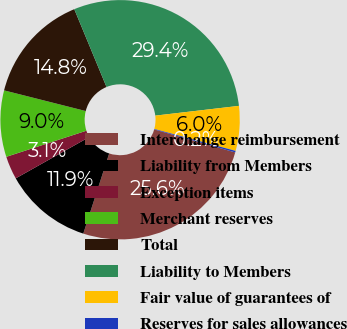Convert chart. <chart><loc_0><loc_0><loc_500><loc_500><pie_chart><fcel>Interchange reimbursement<fcel>Liability from Members<fcel>Exception items<fcel>Merchant reserves<fcel>Total<fcel>Liability to Members<fcel>Fair value of guarantees of<fcel>Reserves for sales allowances<nl><fcel>25.57%<fcel>11.88%<fcel>3.13%<fcel>8.96%<fcel>14.8%<fcel>29.4%<fcel>6.04%<fcel>0.21%<nl></chart> 